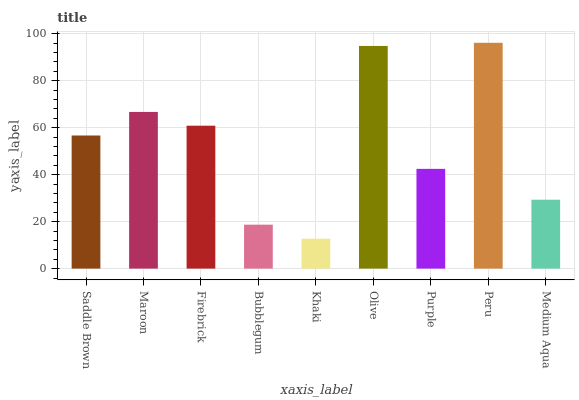Is Maroon the minimum?
Answer yes or no. No. Is Maroon the maximum?
Answer yes or no. No. Is Maroon greater than Saddle Brown?
Answer yes or no. Yes. Is Saddle Brown less than Maroon?
Answer yes or no. Yes. Is Saddle Brown greater than Maroon?
Answer yes or no. No. Is Maroon less than Saddle Brown?
Answer yes or no. No. Is Saddle Brown the high median?
Answer yes or no. Yes. Is Saddle Brown the low median?
Answer yes or no. Yes. Is Maroon the high median?
Answer yes or no. No. Is Olive the low median?
Answer yes or no. No. 